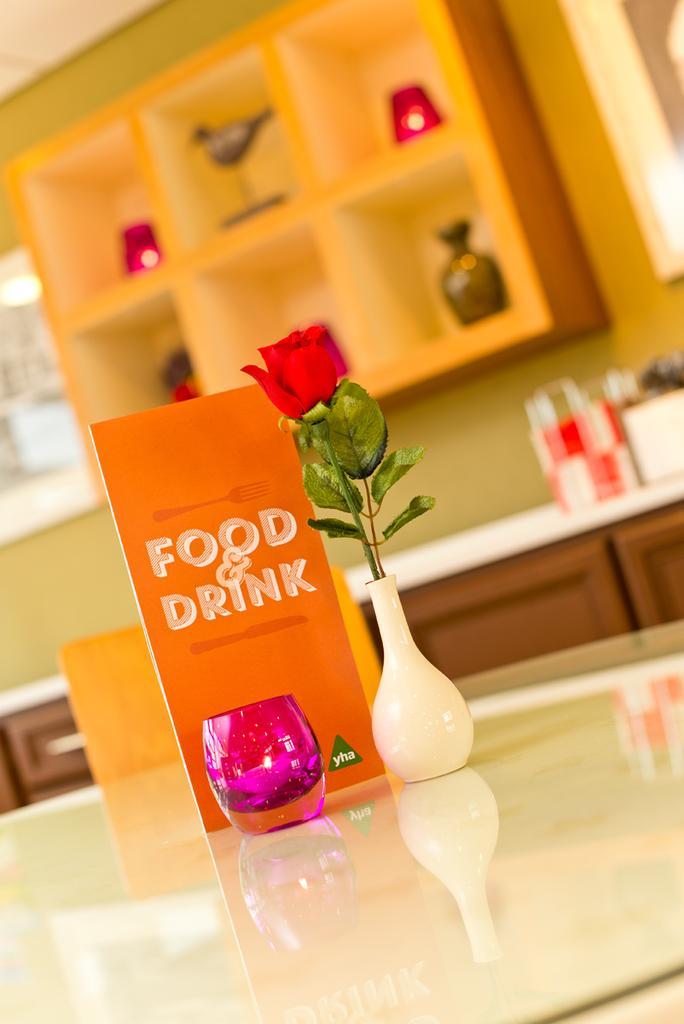Describe this image in one or two sentences. In the image we can see there is a table on which there is glass and a vase kept on a table and in the vase there is a rose flower kept and there is a menu card on which its written "Food & Drink". 